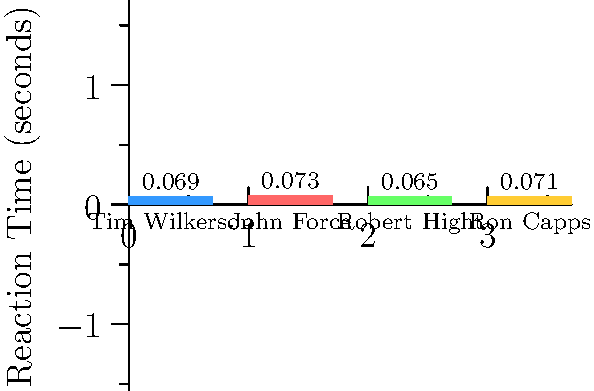Based on the reaction time comparison in the bar graph, which driver has the quickest average reaction time at the starting line, and how does Tim Wilkerson's performance compare to the others? To answer this question, we need to analyze the reaction times presented in the bar graph for each driver:

1. Tim Wilkerson: 0.069 seconds
2. John Force: 0.073 seconds
3. Robert Hight: 0.065 seconds
4. Ron Capps: 0.071 seconds

Step 1: Identify the quickest reaction time
The lowest bar in the graph represents the quickest reaction time. Robert Hight has the shortest bar, with a reaction time of 0.065 seconds.

Step 2: Compare Tim Wilkerson's performance
Tim Wilkerson's reaction time is 0.069 seconds, which is:
- Faster than John Force (0.073 s) and Ron Capps (0.071 s)
- Slower than Robert Hight (0.065 s)
- The second-quickest reaction time among the four drivers

Step 3: Summarize the findings
Robert Hight has the quickest average reaction time at 0.065 seconds. Tim Wilkerson performs well, having the second-quickest reaction time at 0.069 seconds, which is only 0.004 seconds slower than Hight but faster than both Force and Capps.
Answer: Robert Hight; Tim Wilkerson is second-quickest, 0.004s behind Hight. 